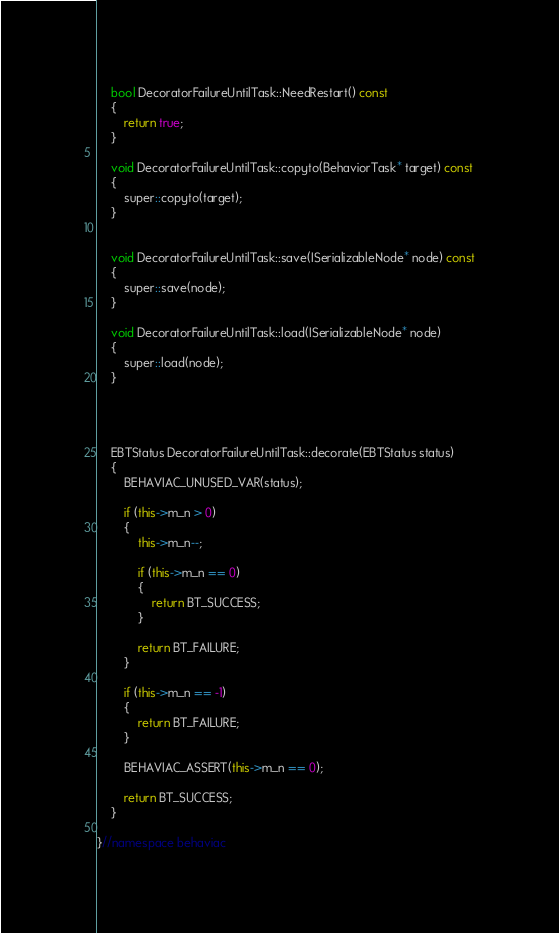Convert code to text. <code><loc_0><loc_0><loc_500><loc_500><_C++_>
	bool DecoratorFailureUntilTask::NeedRestart() const
	{
		return true;
	}

	void DecoratorFailureUntilTask::copyto(BehaviorTask* target) const
	{
		super::copyto(target);
	}


	void DecoratorFailureUntilTask::save(ISerializableNode* node) const
	{
		super::save(node);
	}

	void DecoratorFailureUntilTask::load(ISerializableNode* node)
	{
		super::load(node);
	}




	EBTStatus DecoratorFailureUntilTask::decorate(EBTStatus status)
	{
		BEHAVIAC_UNUSED_VAR(status);

		if (this->m_n > 0)
		{
			this->m_n--;

			if (this->m_n == 0)
			{
				return BT_SUCCESS;
			}

			return BT_FAILURE;
		}

		if (this->m_n == -1)
		{
			return BT_FAILURE;
		}

		BEHAVIAC_ASSERT(this->m_n == 0);

		return BT_SUCCESS;
	}

}//namespace behaviac</code> 